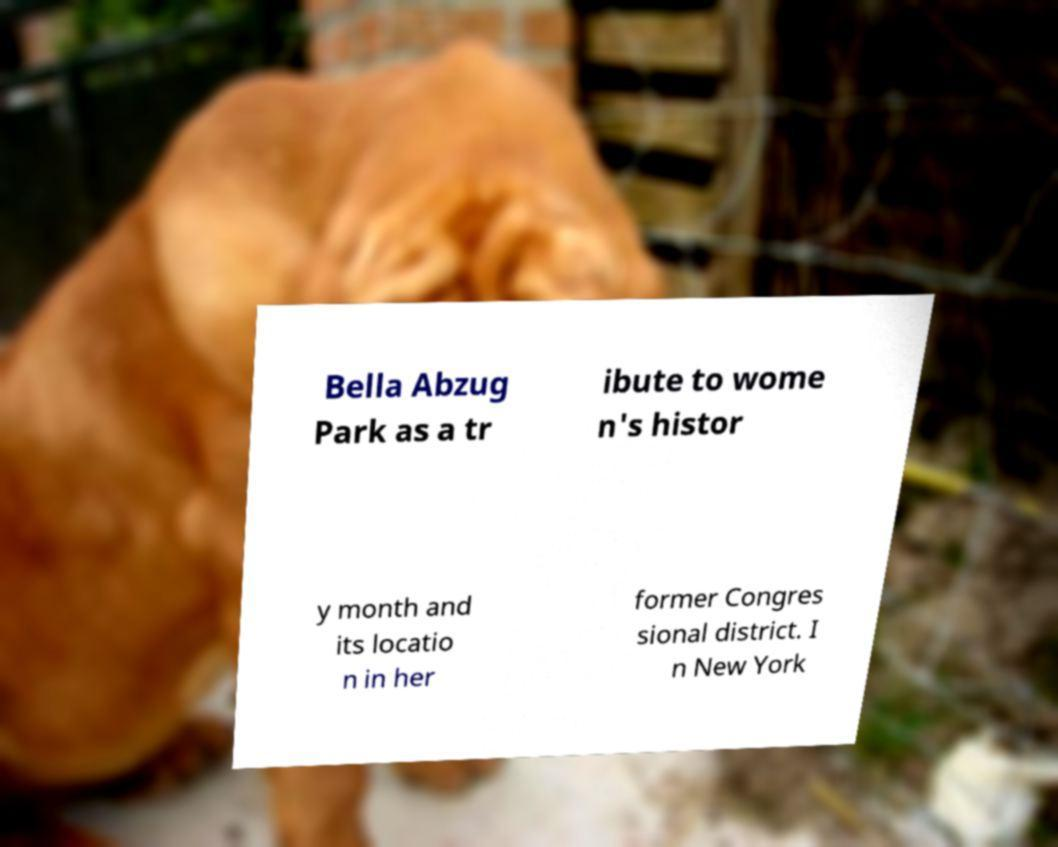Please read and relay the text visible in this image. What does it say? Bella Abzug Park as a tr ibute to wome n's histor y month and its locatio n in her former Congres sional district. I n New York 